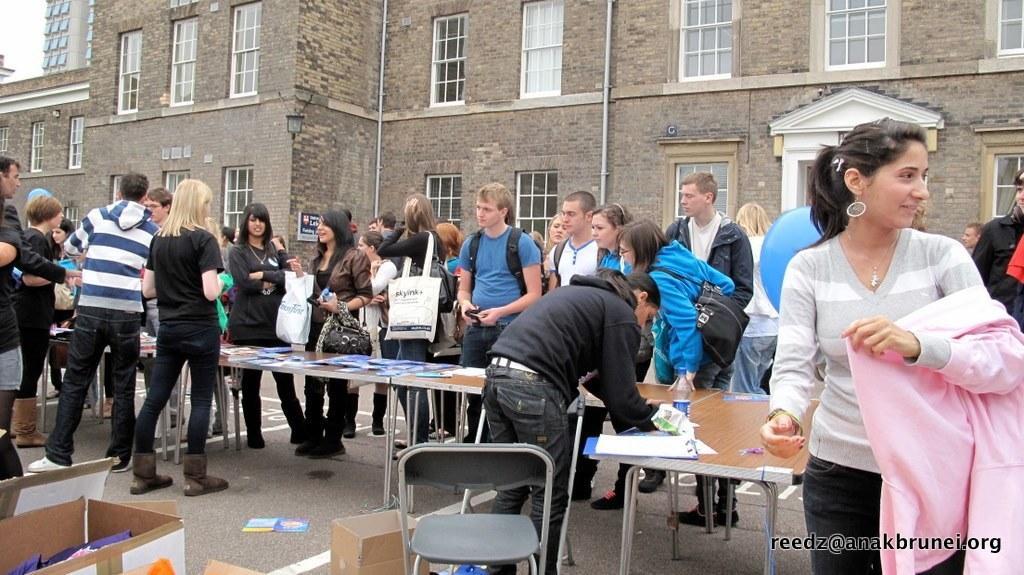Can you describe this image briefly? This image is clicked outside. There are many people in this image. In the front, there are tables on which there are papers. In the background, there is building along with windows and doors. To the right, the woman is wearing pink jacket. 